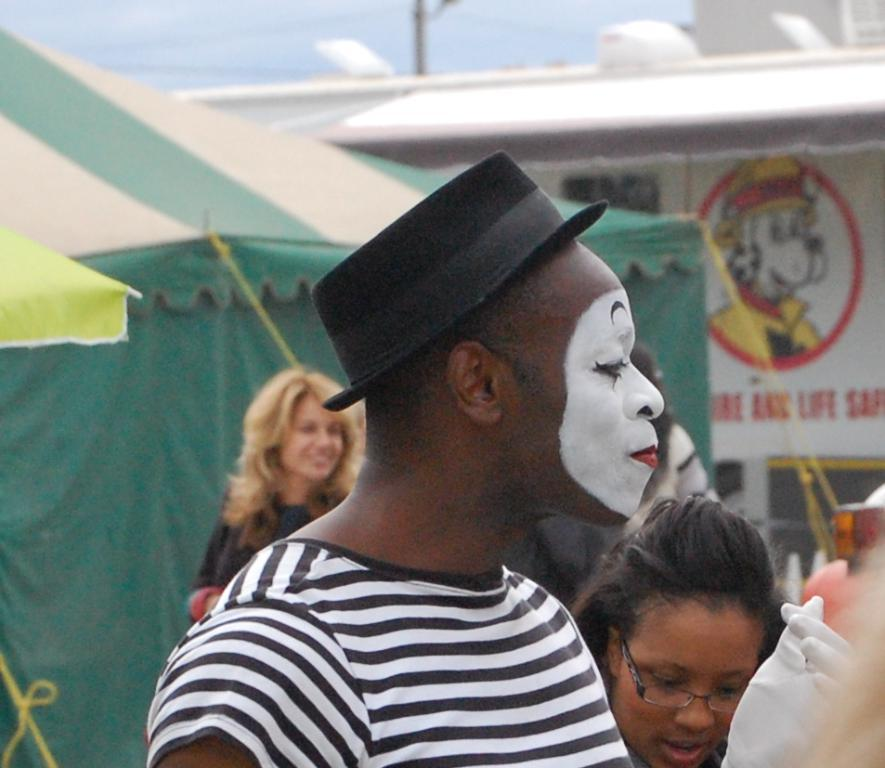How many people are in the image? There are two people in the image. What is unique about one person's appearance? There is a painting on one person's face. Can you describe the background of the image? There is a background in the image that includes people, a tent, a poster, a pole, and the sky. What type of ship can be seen sailing in the background of the image? There is no ship visible in the background of the image. Is there a lamp illuminating the scene in the image? There is no lamp present in the image. 